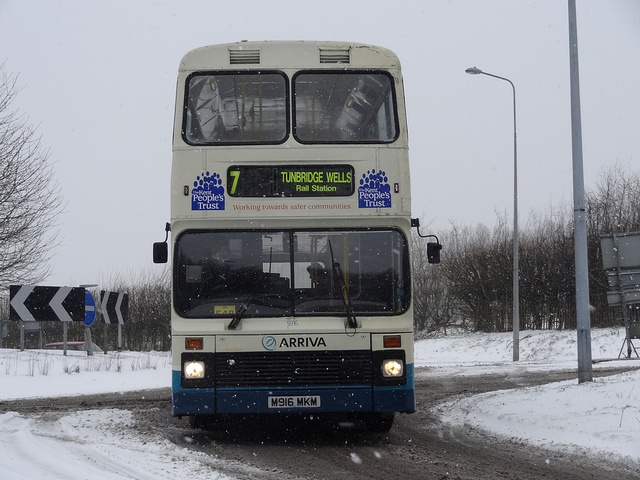Describe the objects in this image and their specific colors. I can see bus in lightgray, black, darkgray, gray, and navy tones, people in lightgray, black, and gray tones, and people in lightgray, black, and gray tones in this image. 